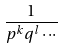<formula> <loc_0><loc_0><loc_500><loc_500>\frac { 1 } { p ^ { k } q ^ { l } \cdot \cdot \cdot }</formula> 